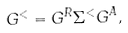Convert formula to latex. <formula><loc_0><loc_0><loc_500><loc_500>G ^ { < } = G ^ { R } \Sigma ^ { < } G ^ { A } ,</formula> 